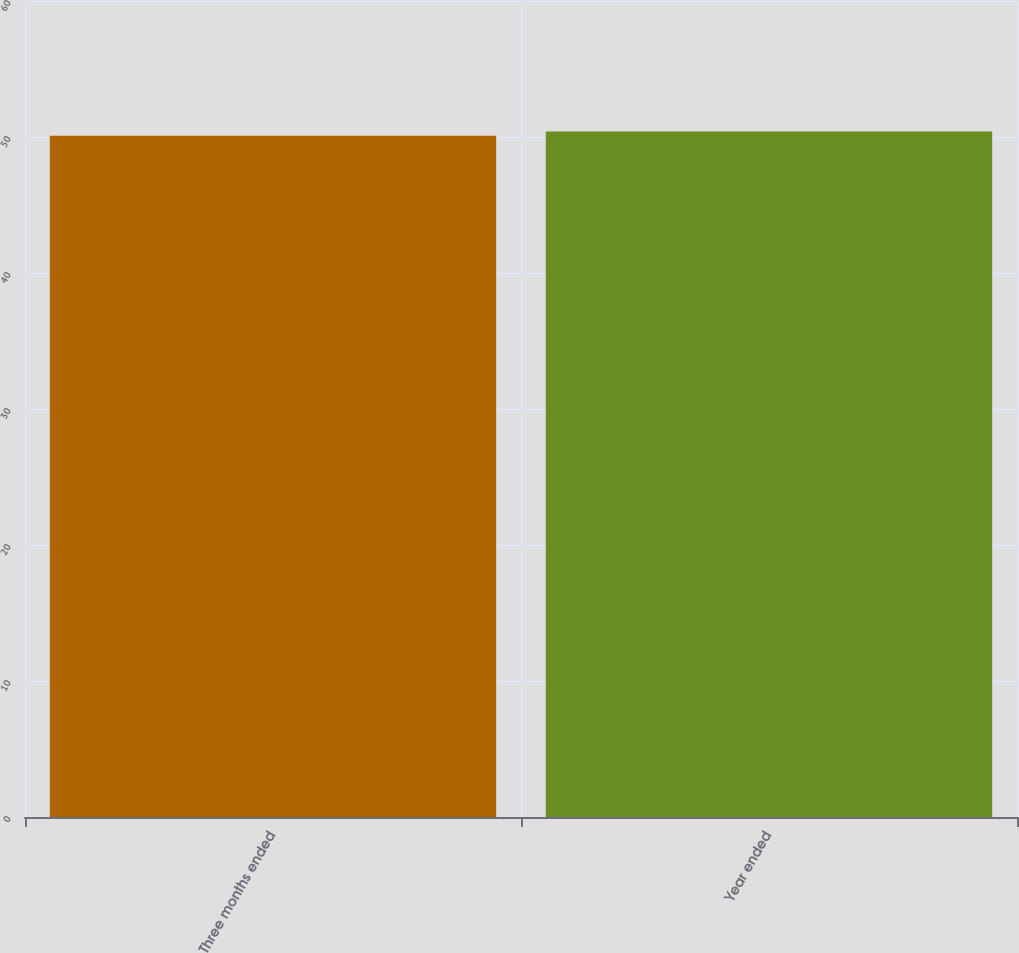Convert chart. <chart><loc_0><loc_0><loc_500><loc_500><bar_chart><fcel>Three months ended<fcel>Year ended<nl><fcel>50.1<fcel>50.4<nl></chart> 